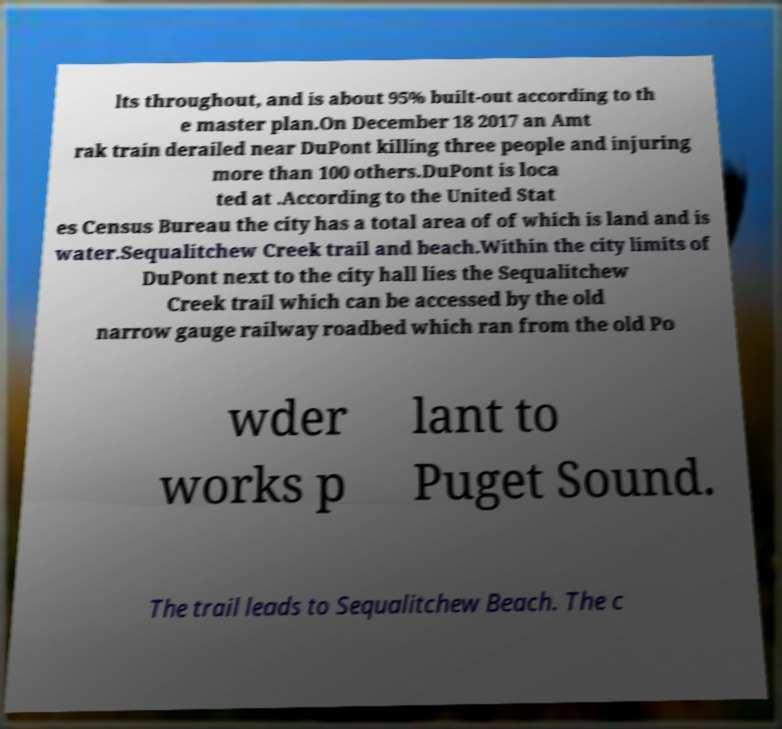Please read and relay the text visible in this image. What does it say? lts throughout, and is about 95% built-out according to th e master plan.On December 18 2017 an Amt rak train derailed near DuPont killing three people and injuring more than 100 others.DuPont is loca ted at .According to the United Stat es Census Bureau the city has a total area of of which is land and is water.Sequalitchew Creek trail and beach.Within the city limits of DuPont next to the city hall lies the Sequalitchew Creek trail which can be accessed by the old narrow gauge railway roadbed which ran from the old Po wder works p lant to Puget Sound. The trail leads to Sequalitchew Beach. The c 